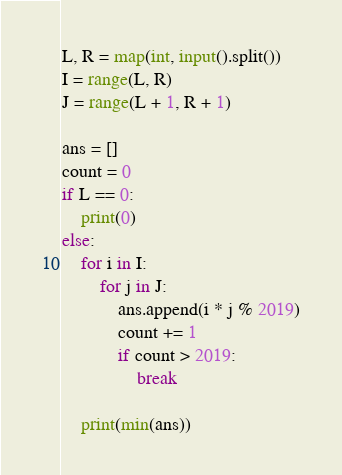Convert code to text. <code><loc_0><loc_0><loc_500><loc_500><_Python_>L, R = map(int, input().split())
I = range(L, R)
J = range(L + 1, R + 1)

ans = []
count = 0
if L == 0:
    print(0)
else:
    for i in I:
        for j in J:
            ans.append(i * j % 2019)
            count += 1
            if count > 2019:
                break
            
    print(min(ans))</code> 